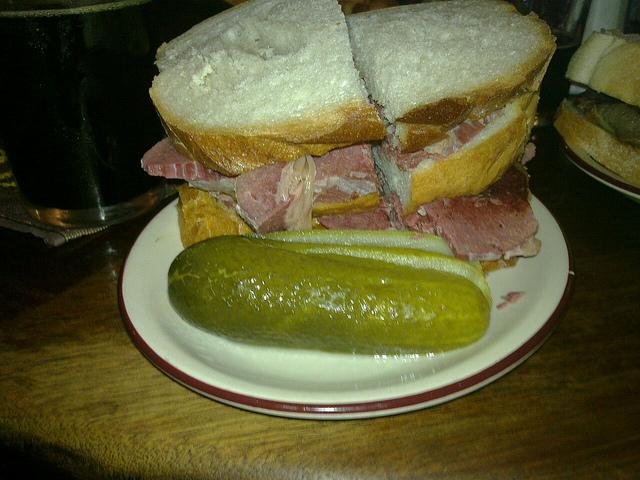What taste does the green food have?

Choices:
A) sour
B) sweet
C) spicy
D) bitter sour 